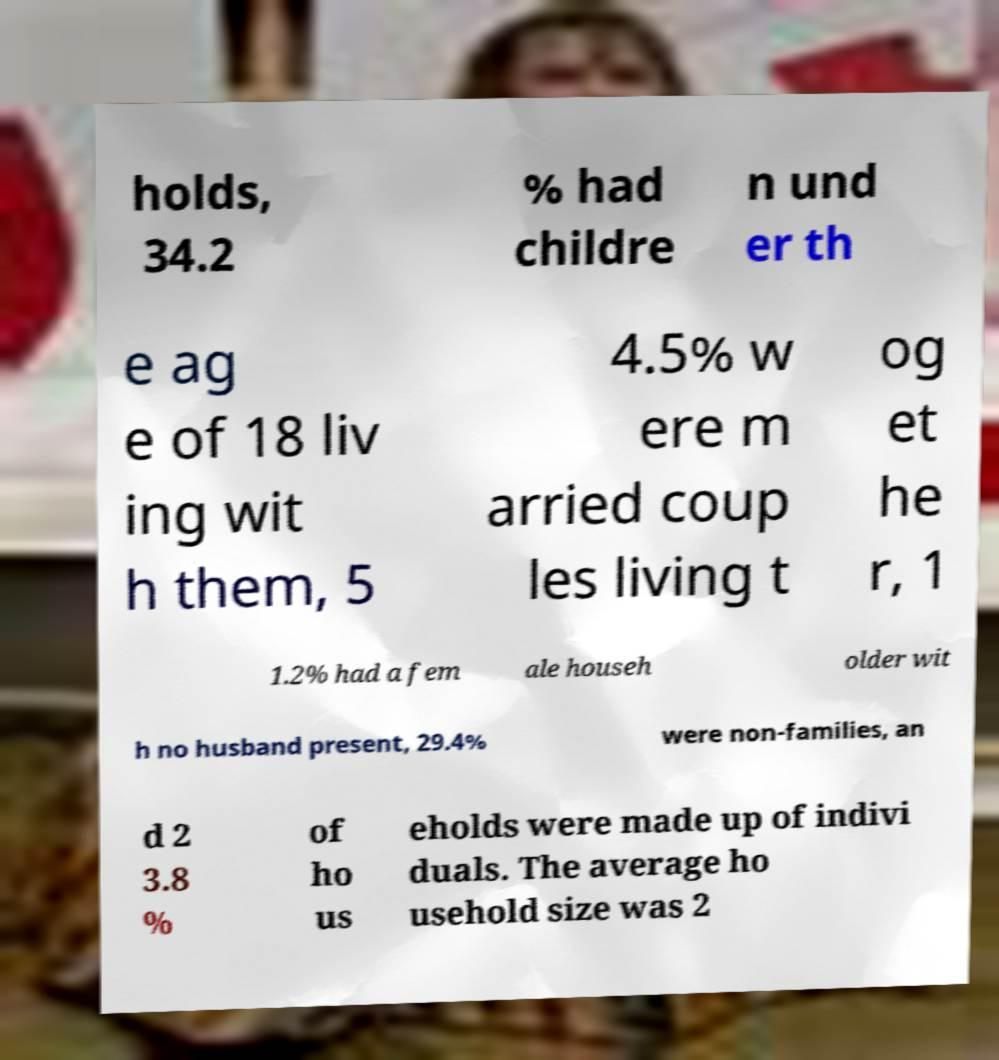Could you assist in decoding the text presented in this image and type it out clearly? holds, 34.2 % had childre n und er th e ag e of 18 liv ing wit h them, 5 4.5% w ere m arried coup les living t og et he r, 1 1.2% had a fem ale househ older wit h no husband present, 29.4% were non-families, an d 2 3.8 % of ho us eholds were made up of indivi duals. The average ho usehold size was 2 